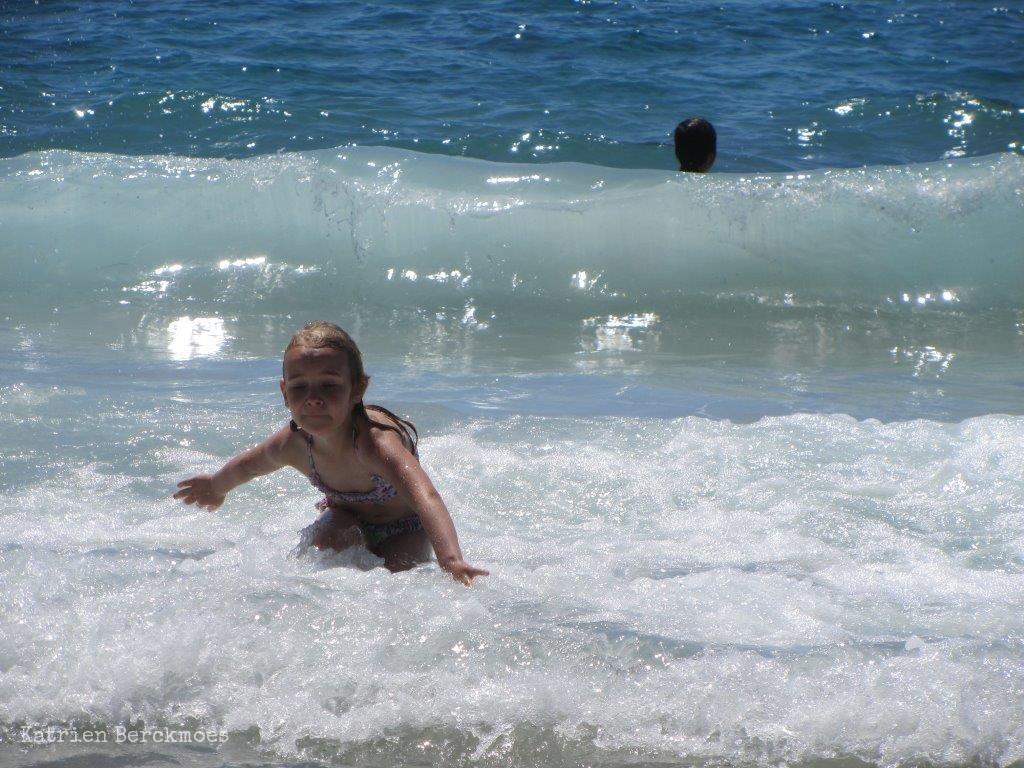Please provide a concise description of this image. In this image we can see children playing in the water. 